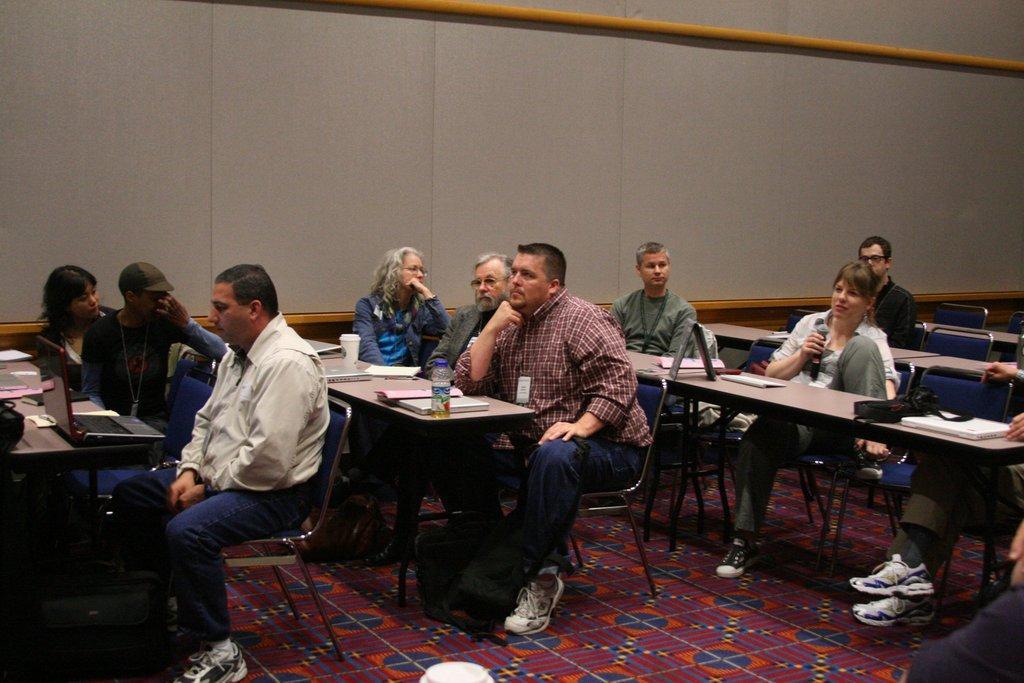Can you describe this image briefly? In this picture there are a group of people sitting and there is a microphone in this woman's hand and on the floor there is a carpet 